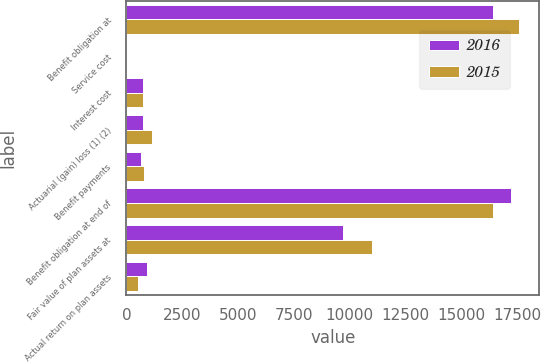Convert chart. <chart><loc_0><loc_0><loc_500><loc_500><stacked_bar_chart><ecel><fcel>Benefit obligation at<fcel>Service cost<fcel>Interest cost<fcel>Actuarial (gain) loss (1) (2)<fcel>Benefit payments<fcel>Benefit obligation at end of<fcel>Fair value of plan assets at<fcel>Actual return on plan assets<nl><fcel>2016<fcel>16395<fcel>2<fcel>749<fcel>729<fcel>635<fcel>17238<fcel>9707<fcel>915<nl><fcel>2015<fcel>17594<fcel>2<fcel>737<fcel>1159<fcel>776<fcel>16395<fcel>10986<fcel>506<nl></chart> 